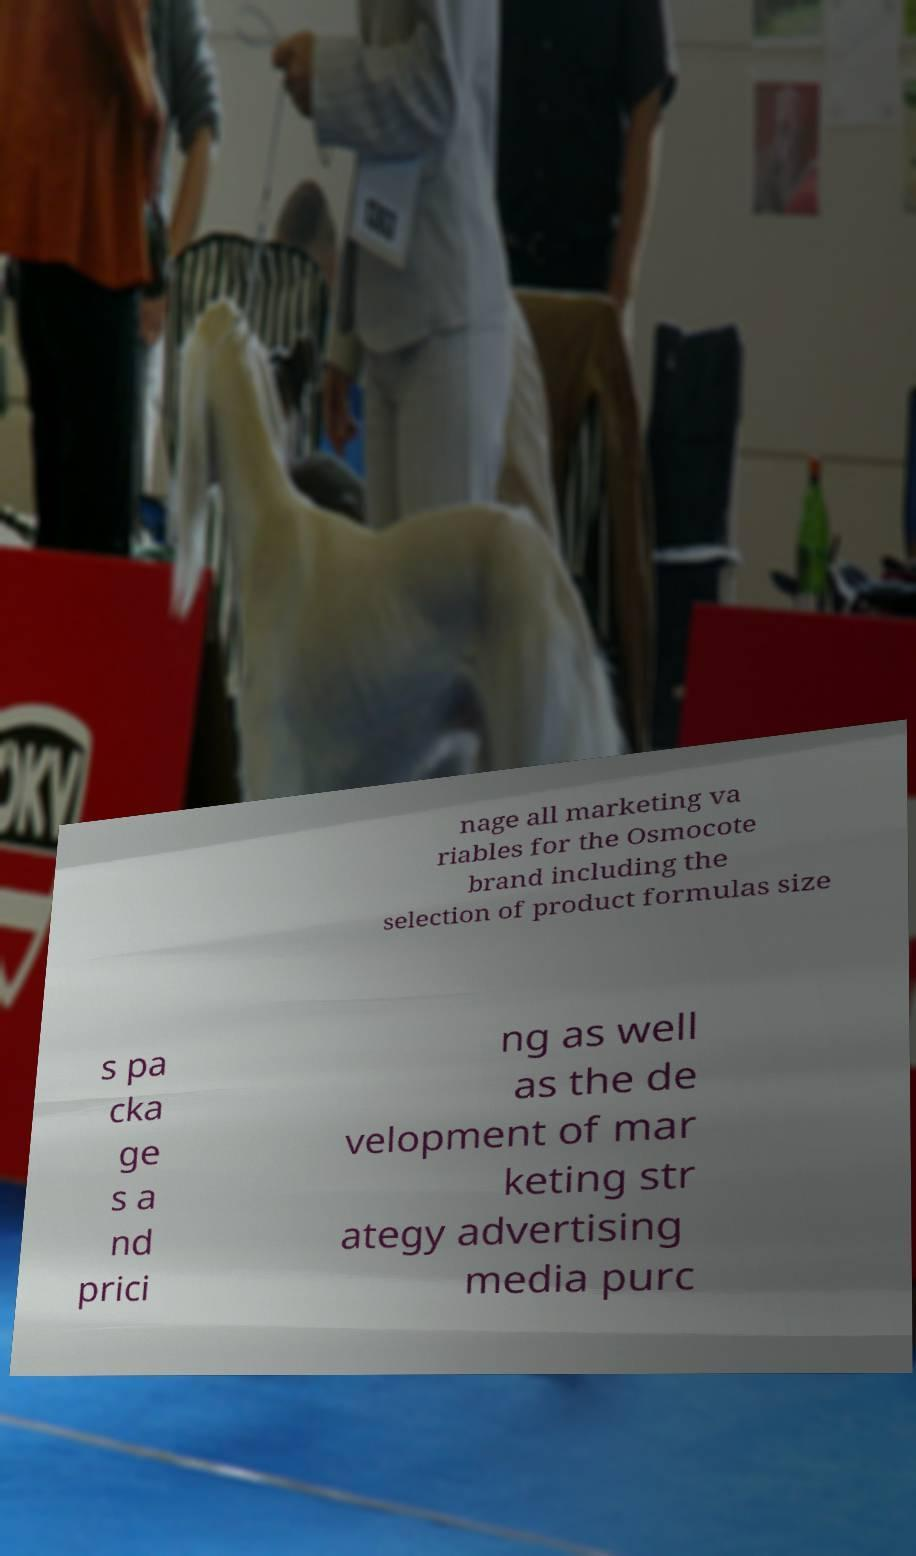Please identify and transcribe the text found in this image. nage all marketing va riables for the Osmocote brand including the selection of product formulas size s pa cka ge s a nd prici ng as well as the de velopment of mar keting str ategy advertising media purc 